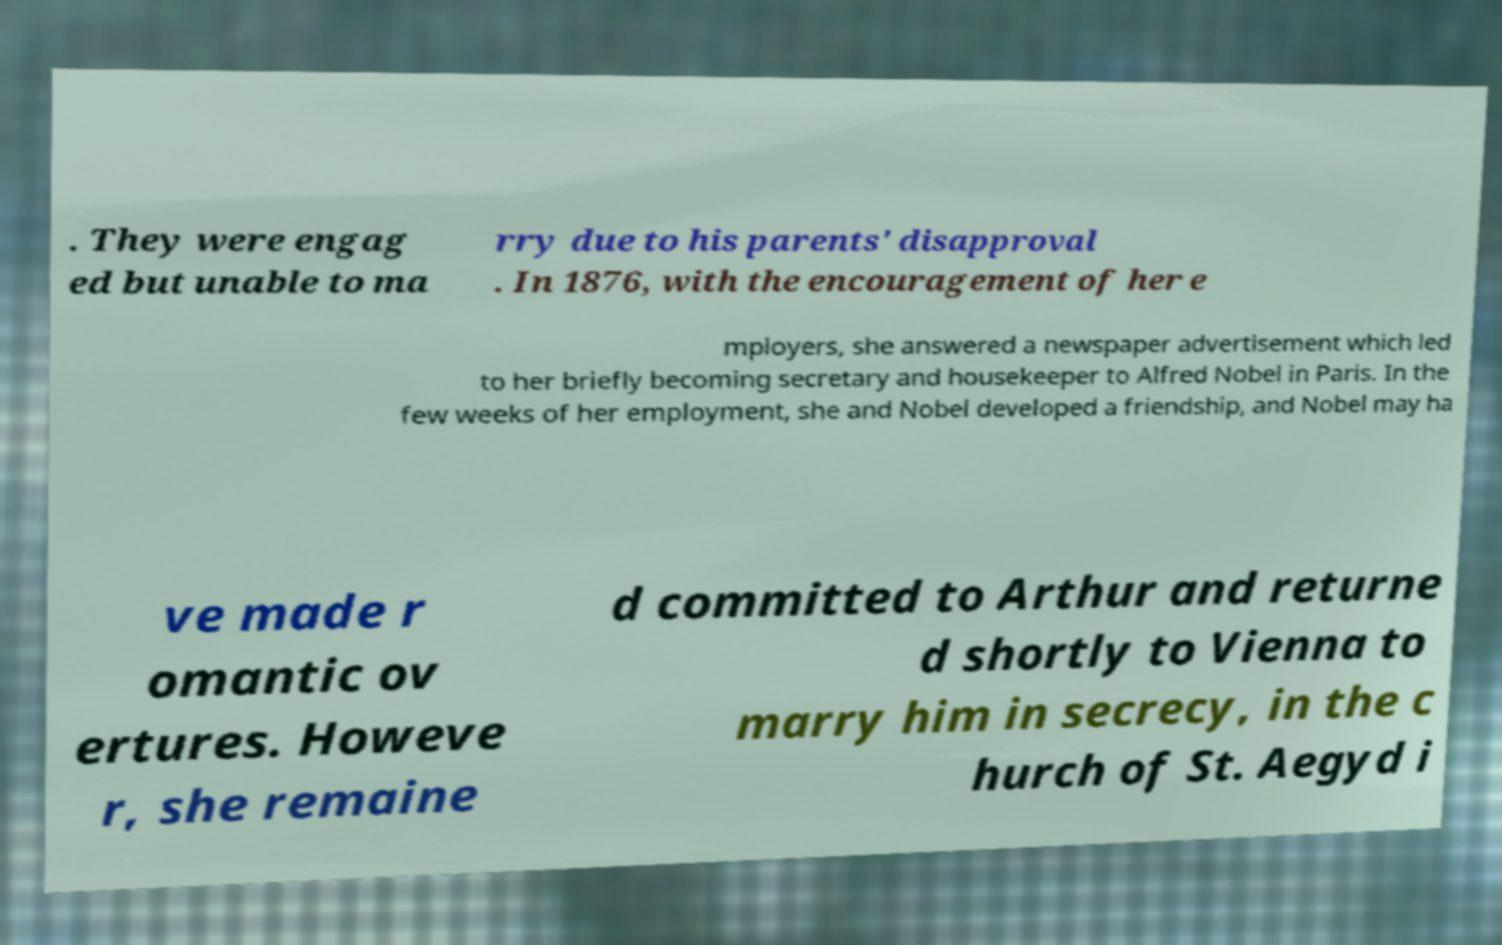Please read and relay the text visible in this image. What does it say? . They were engag ed but unable to ma rry due to his parents' disapproval . In 1876, with the encouragement of her e mployers, she answered a newspaper advertisement which led to her briefly becoming secretary and housekeeper to Alfred Nobel in Paris. In the few weeks of her employment, she and Nobel developed a friendship, and Nobel may ha ve made r omantic ov ertures. Howeve r, she remaine d committed to Arthur and returne d shortly to Vienna to marry him in secrecy, in the c hurch of St. Aegyd i 